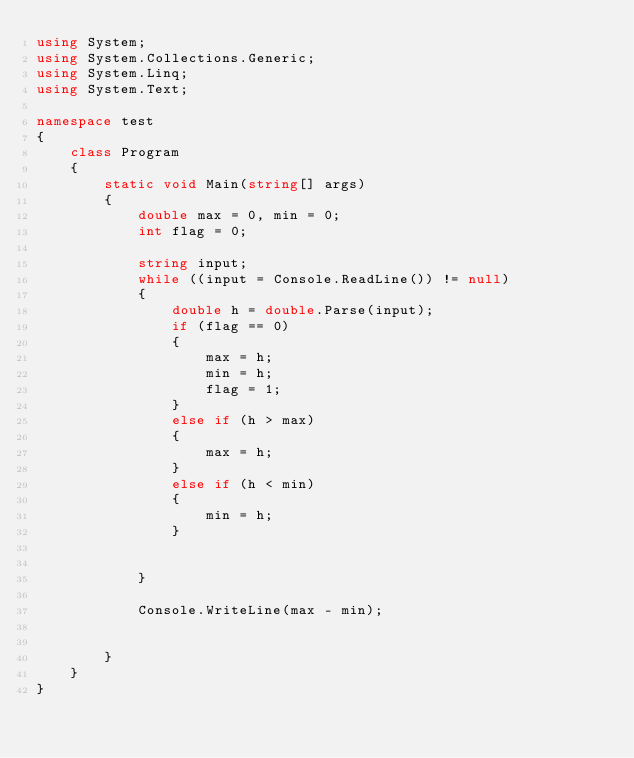Convert code to text. <code><loc_0><loc_0><loc_500><loc_500><_C#_>using System;
using System.Collections.Generic;
using System.Linq;
using System.Text;

namespace test
{
    class Program
    {
        static void Main(string[] args)
        {
            double max = 0, min = 0;
            int flag = 0;

            string input;
            while ((input = Console.ReadLine()) != null)
            {
                double h = double.Parse(input);
                if (flag == 0)
                {
                    max = h;
                    min = h;
                    flag = 1;
                }
                else if (h > max)
                {
                    max = h;
                }
                else if (h < min)
                {
                    min = h;
                }


            }

            Console.WriteLine(max - min);


        }
    }
}</code> 